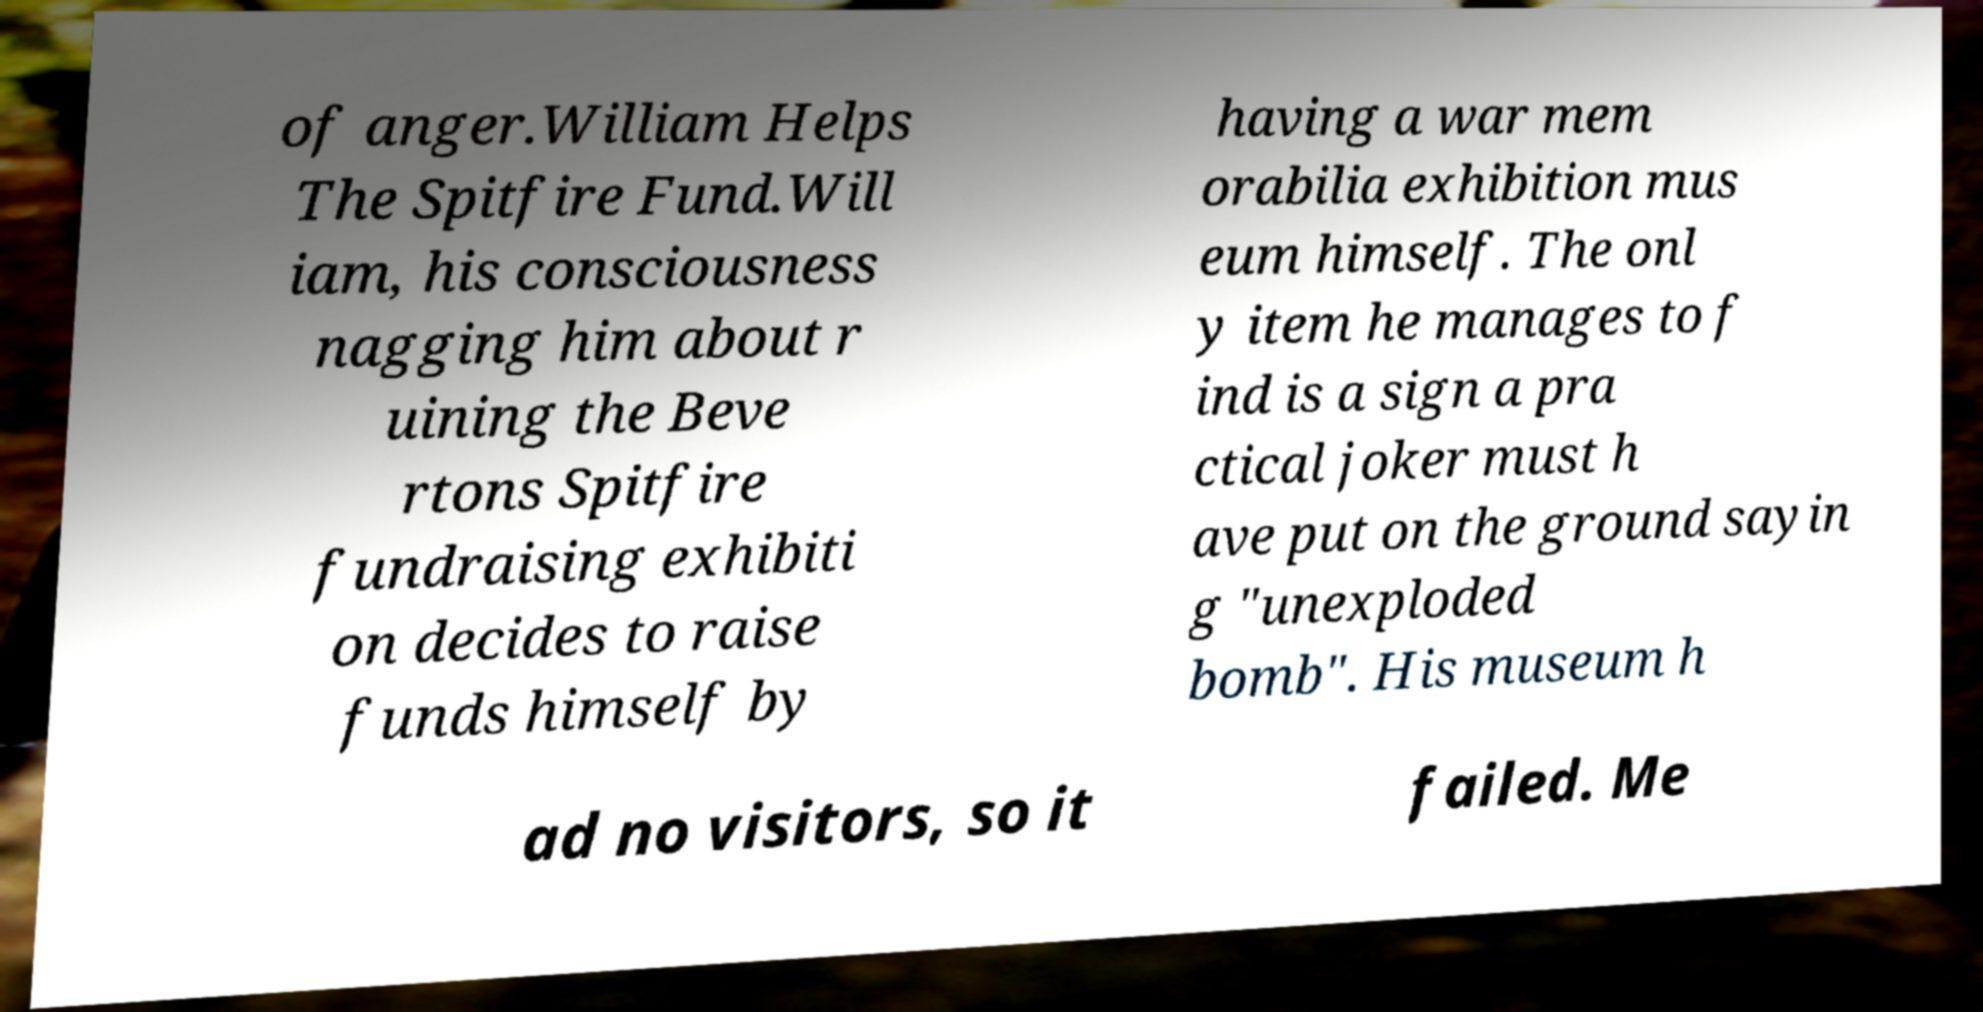Could you assist in decoding the text presented in this image and type it out clearly? of anger.William Helps The Spitfire Fund.Will iam, his consciousness nagging him about r uining the Beve rtons Spitfire fundraising exhibiti on decides to raise funds himself by having a war mem orabilia exhibition mus eum himself. The onl y item he manages to f ind is a sign a pra ctical joker must h ave put on the ground sayin g "unexploded bomb". His museum h ad no visitors, so it failed. Me 